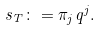Convert formula to latex. <formula><loc_0><loc_0><loc_500><loc_500>s _ { T } \colon = \pi _ { j } q ^ { j } .</formula> 